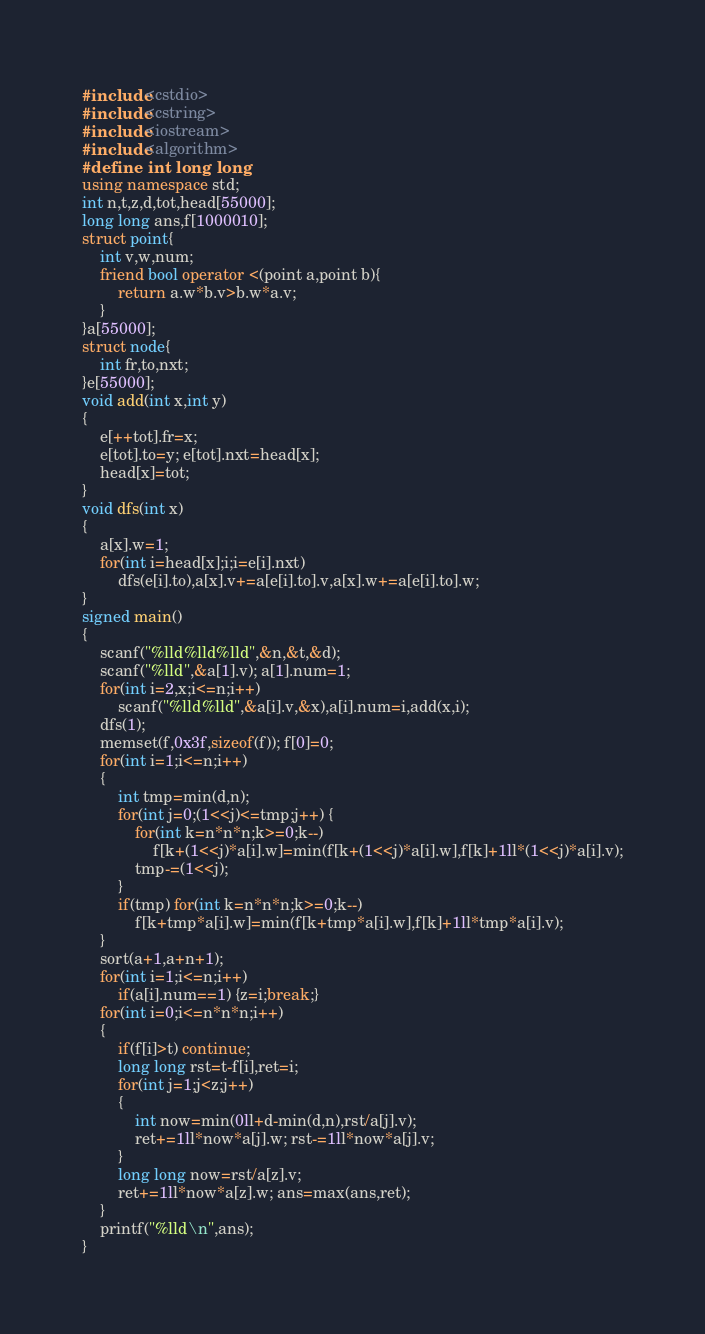Convert code to text. <code><loc_0><loc_0><loc_500><loc_500><_C++_>#include<cstdio>
#include<cstring>
#include<iostream>
#include<algorithm>
#define int long long
using namespace std;
int n,t,z,d,tot,head[55000];
long long ans,f[1000010];
struct point{
	int v,w,num;
	friend bool operator <(point a,point b){
		return a.w*b.v>b.w*a.v;
	}
}a[55000];
struct node{
	int fr,to,nxt;	
}e[55000];
void add(int x,int y)
{
	e[++tot].fr=x;
	e[tot].to=y; e[tot].nxt=head[x];
	head[x]=tot;
}
void dfs(int x)
{
	a[x].w=1; 
	for(int i=head[x];i;i=e[i].nxt)
		dfs(e[i].to),a[x].v+=a[e[i].to].v,a[x].w+=a[e[i].to].w;
}
signed main()
{
	scanf("%lld%lld%lld",&n,&t,&d);
	scanf("%lld",&a[1].v); a[1].num=1;
	for(int i=2,x;i<=n;i++)
		scanf("%lld%lld",&a[i].v,&x),a[i].num=i,add(x,i);
	dfs(1);
	memset(f,0x3f,sizeof(f)); f[0]=0;
	for(int i=1;i<=n;i++)
	{
		int tmp=min(d,n);
		for(int j=0;(1<<j)<=tmp;j++) {
			for(int k=n*n*n;k>=0;k--)
				f[k+(1<<j)*a[i].w]=min(f[k+(1<<j)*a[i].w],f[k]+1ll*(1<<j)*a[i].v);
			tmp-=(1<<j);
		}
		if(tmp) for(int k=n*n*n;k>=0;k--)
			f[k+tmp*a[i].w]=min(f[k+tmp*a[i].w],f[k]+1ll*tmp*a[i].v);
	}
	sort(a+1,a+n+1);
	for(int i=1;i<=n;i++) 
		if(a[i].num==1) {z=i;break;}
	for(int i=0;i<=n*n*n;i++)
	{
		if(f[i]>t) continue;
		long long rst=t-f[i],ret=i;
		for(int j=1;j<z;j++)
		{
			int now=min(0ll+d-min(d,n),rst/a[j].v);
			ret+=1ll*now*a[j].w; rst-=1ll*now*a[j].v;
		}
		long long now=rst/a[z].v;
		ret+=1ll*now*a[z].w; ans=max(ans,ret);
	} 
	printf("%lld\n",ans);
}</code> 